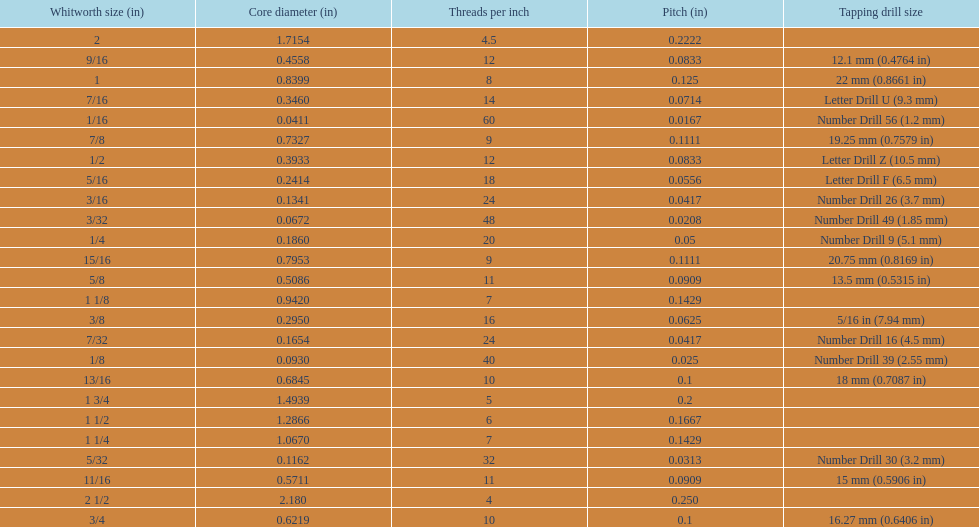What are all the whitworth sizes? 1/16, 3/32, 1/8, 5/32, 3/16, 7/32, 1/4, 5/16, 3/8, 7/16, 1/2, 9/16, 5/8, 11/16, 3/4, 13/16, 7/8, 15/16, 1, 1 1/8, 1 1/4, 1 1/2, 1 3/4, 2, 2 1/2. What are the threads per inch of these sizes? 60, 48, 40, 32, 24, 24, 20, 18, 16, 14, 12, 12, 11, 11, 10, 10, 9, 9, 8, 7, 7, 6, 5, 4.5, 4. Of these, which are 5? 5. What whitworth size has this threads per inch? 1 3/4. 